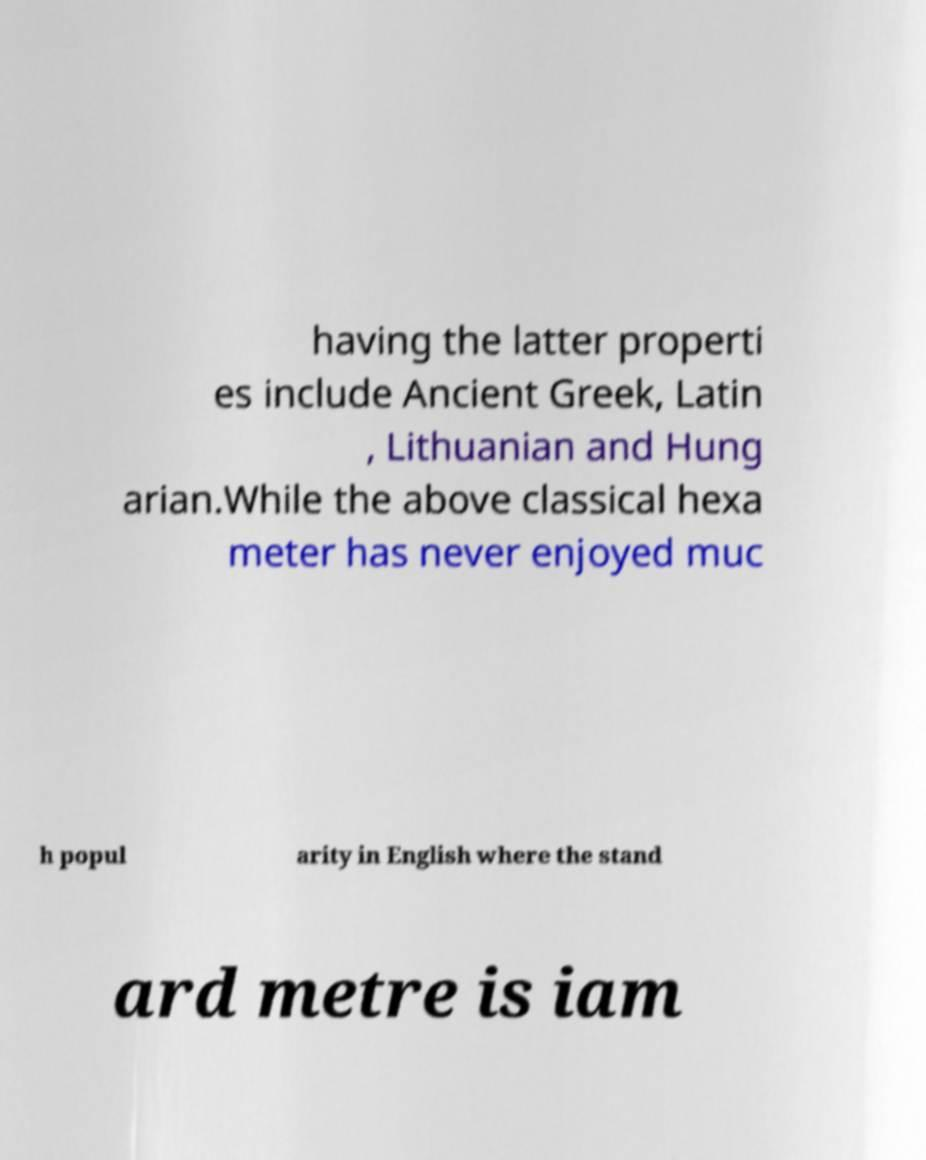Could you assist in decoding the text presented in this image and type it out clearly? having the latter properti es include Ancient Greek, Latin , Lithuanian and Hung arian.While the above classical hexa meter has never enjoyed muc h popul arity in English where the stand ard metre is iam 